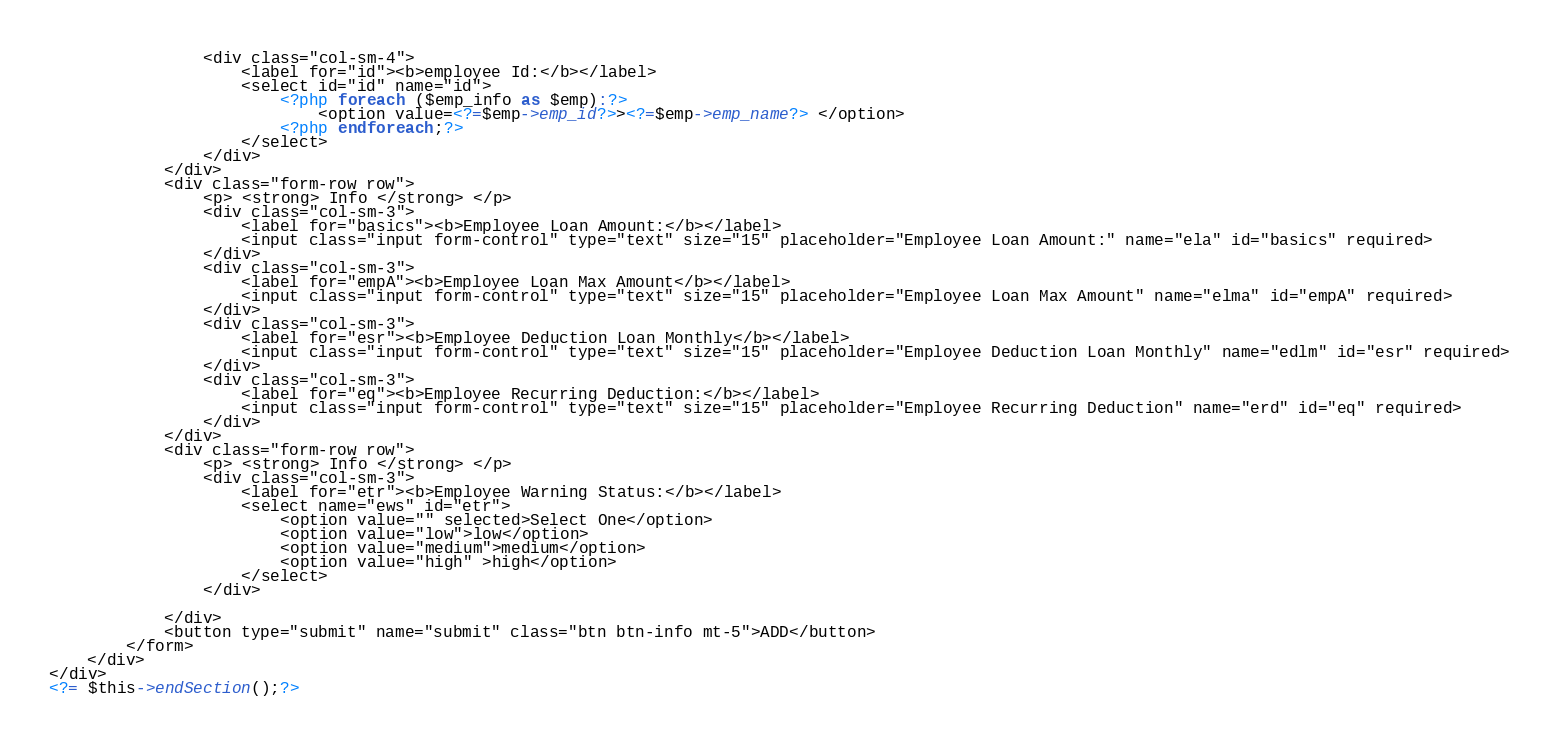Convert code to text. <code><loc_0><loc_0><loc_500><loc_500><_PHP_>                <div class="col-sm-4">
                    <label for="id"><b>employee Id:</b></label>
                    <select id="id" name="id">
                        <?php foreach ($emp_info as $emp):?>
                            <option value=<?=$emp->emp_id?>><?=$emp->emp_name?> </option>
                        <?php endforeach;?>
                    </select>
                </div>
            </div>
            <div class="form-row row">
                <p> <strong> Info </strong> </p>
                <div class="col-sm-3">
                    <label for="basics"><b>Employee Loan Amount:</b></label>
                    <input class="input form-control" type="text" size="15" placeholder="Employee Loan Amount:" name="ela" id="basics" required>
                </div>
                <div class="col-sm-3">
                    <label for="empA"><b>Employee Loan Max Amount</b></label>
                    <input class="input form-control" type="text" size="15" placeholder="Employee Loan Max Amount" name="elma" id="empA" required>
                </div>
                <div class="col-sm-3">
                    <label for="esr"><b>Employee Deduction Loan Monthly</b></label>
                    <input class="input form-control" type="text" size="15" placeholder="Employee Deduction Loan Monthly" name="edlm" id="esr" required>
                </div>
                <div class="col-sm-3">
                    <label for="eq"><b>Employee Recurring Deduction:</b></label>
                    <input class="input form-control" type="text" size="15" placeholder="Employee Recurring Deduction" name="erd" id="eq" required>
                </div>
            </div>
            <div class="form-row row">
                <p> <strong> Info </strong> </p>
                <div class="col-sm-3">
                    <label for="etr"><b>Employee Warning Status:</b></label>
                    <select name="ews" id="etr">
                        <option value="" selected>Select One</option>
                        <option value="low">low</option>
                        <option value="medium">medium</option>
                        <option value="high" >high</option>
                    </select>
                </div>

            </div>
            <button type="submit" name="submit" class="btn btn-info mt-5">ADD</button>
        </form>
    </div>
</div>
<?= $this->endSection();?>
</code> 